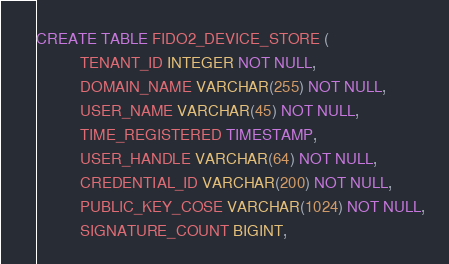Convert code to text. <code><loc_0><loc_0><loc_500><loc_500><_SQL_>CREATE TABLE FIDO2_DEVICE_STORE (
          TENANT_ID INTEGER NOT NULL,
          DOMAIN_NAME VARCHAR(255) NOT NULL,
          USER_NAME VARCHAR(45) NOT NULL,
          TIME_REGISTERED TIMESTAMP,
          USER_HANDLE VARCHAR(64) NOT NULL,
          CREDENTIAL_ID VARCHAR(200) NOT NULL,
          PUBLIC_KEY_COSE VARCHAR(1024) NOT NULL,
          SIGNATURE_COUNT BIGINT,</code> 